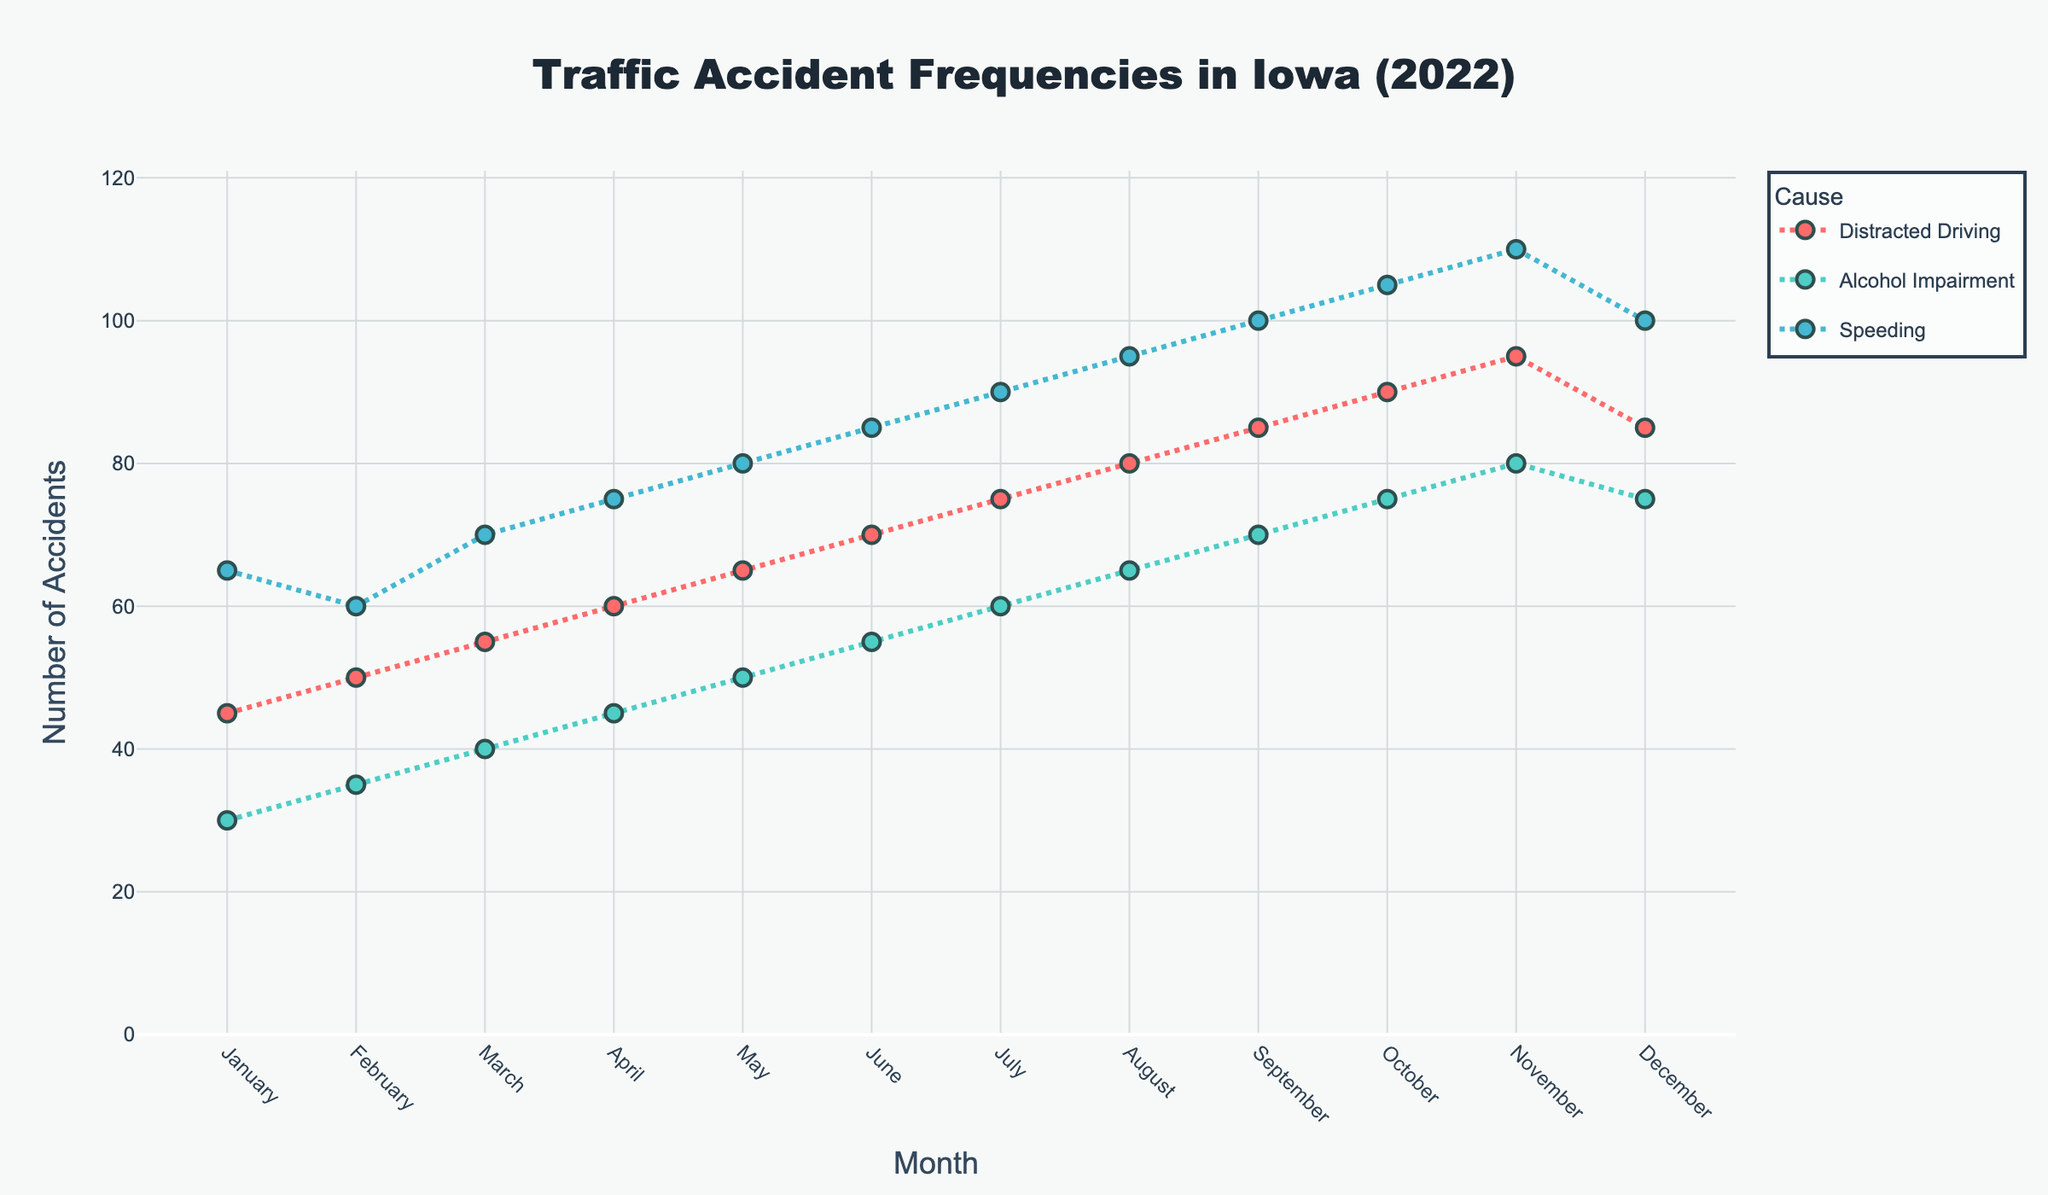How many total accidents were recorded due to Alcohol Impairment throughout 2022? To find the total number of accidents due to Alcohol Impairment, sum the values across all months for 'Alcohol Impairment'. This includes: 30 (January) + 35 (February) + 40 (March) + 45 (April) + 50 (May) + 55 (June) + 60 (July) + 65 (August) + 70 (September) + 75 (October) + 80 (November) + 75 (December). The total sum is 680.
Answer: 680 What is the month with the highest number of speeding-related accidents? Look at the scatter plot and find the highest data point for 'Speeding'. The highest value is 110, which occurs in November.
Answer: November Which cause had the highest increase in accidents from January to December? Compare the number of accidents for each cause in January and December. For Distracted Driving: 45 (January) to 85 (December) = +40. For Alcohol Impairment: 30 (January) to 75 (December) = +45. For Speeding: 65 (January) to 100 (December) = +35. Hence, Alcohol Impairment had the highest increase of +45 accidents.
Answer: Alcohol Impairment Which cause shows the most consistent increase in number of accidents over the months? Consistency can be determined by observing the trend of the lines and markers. Speeding exhibits a consistent and steady increase each month.
Answer: Speeding What is the average number of distracted driving accidents per month? Sum the number of distracted driving accidents from all months and divide by 12. The sum is 850 and dividing it by 12 gives the average: 850/12 ≈ 70.83.
Answer: 70.83 During which month did accidents related to Alcohol Impairment surpass those due to Distracted Driving? Identify the specific month where the data point for 'Alcohol Impairment' is above 'Distracted Driving'. This transition occurs in November when Alcohol Impairment has 80 accidents while Distracted Driving has 75.
Answer: November How many months had fewer than 50 traffic accidents due to Alcohol Impairment? Count the months where the number of accidents due to Alcohol Impairment is less than 50. These months are January (30), February (35), March (40), and April (45). Therefore, there are 4 such months.
Answer: 4 In which month did all three causes have the highest combined total number of accidents? For each month, sum the three causes’ accidents and identify the month with the highest total. November has the highest combined total: 95 (Distracted Driving) + 80 (Alcohol Impairment) + 110 (Speeding) = 285.
Answer: November Which cause witnessed a drop in the number of accidents from November to December? Look at the scatter plot for the numbers in November and December, and identify any decreases. Distracted Driving went from 95 (November) to 85 (December), Alcohol Impairment from 80 to 75, and Speeding from 110 to 100. All three causes witnessed drops.
Answer: All causes 